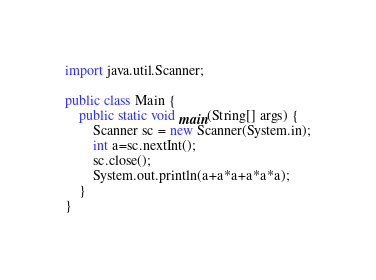<code> <loc_0><loc_0><loc_500><loc_500><_Java_>import java.util.Scanner;

public class Main {
	public static void main(String[] args) {
		Scanner sc = new Scanner(System.in);
		int a=sc.nextInt();
		sc.close();
		System.out.println(a+a*a+a*a*a);
	}
}
</code> 